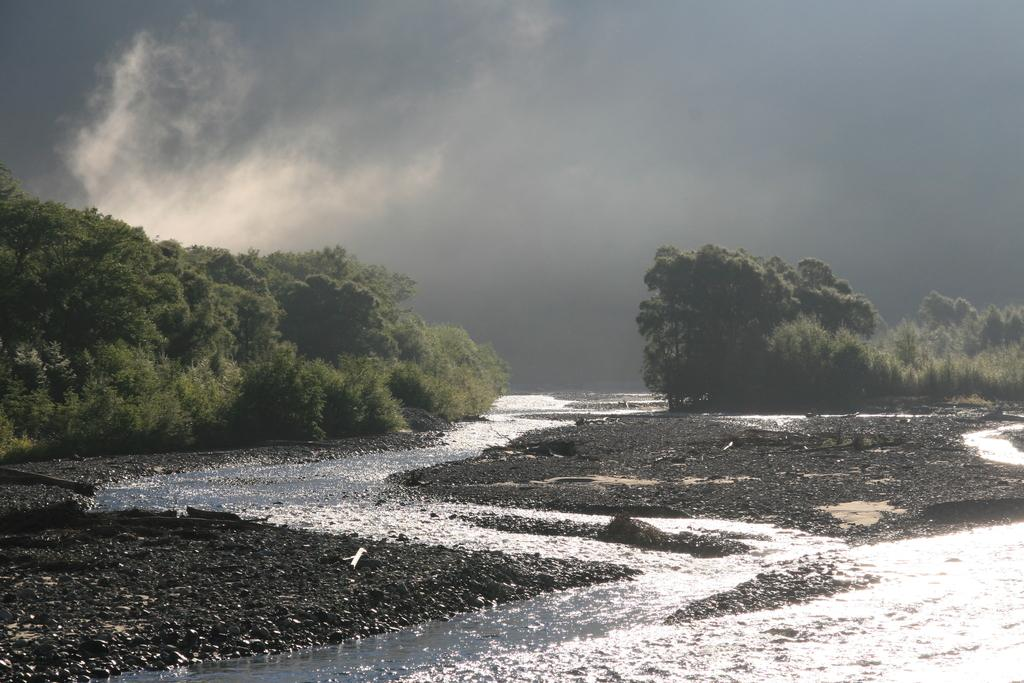What is visible in the image? There is water visible in the image. What can be seen in the background of the image? There are trees in the background of the image. How would you describe the sky in the image? The sky is cloudy in the image. Can you see a station in the image? There is no station present in the image. Is there a bee buzzing around the trees in the image? There is no bee visible in the image. 